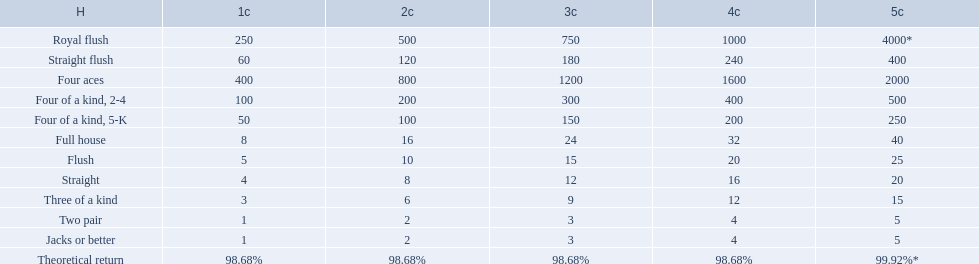What are the hands? Royal flush, Straight flush, Four aces, Four of a kind, 2-4, Four of a kind, 5-K, Full house, Flush, Straight, Three of a kind, Two pair, Jacks or better. Which hand is on the top? Royal flush. 